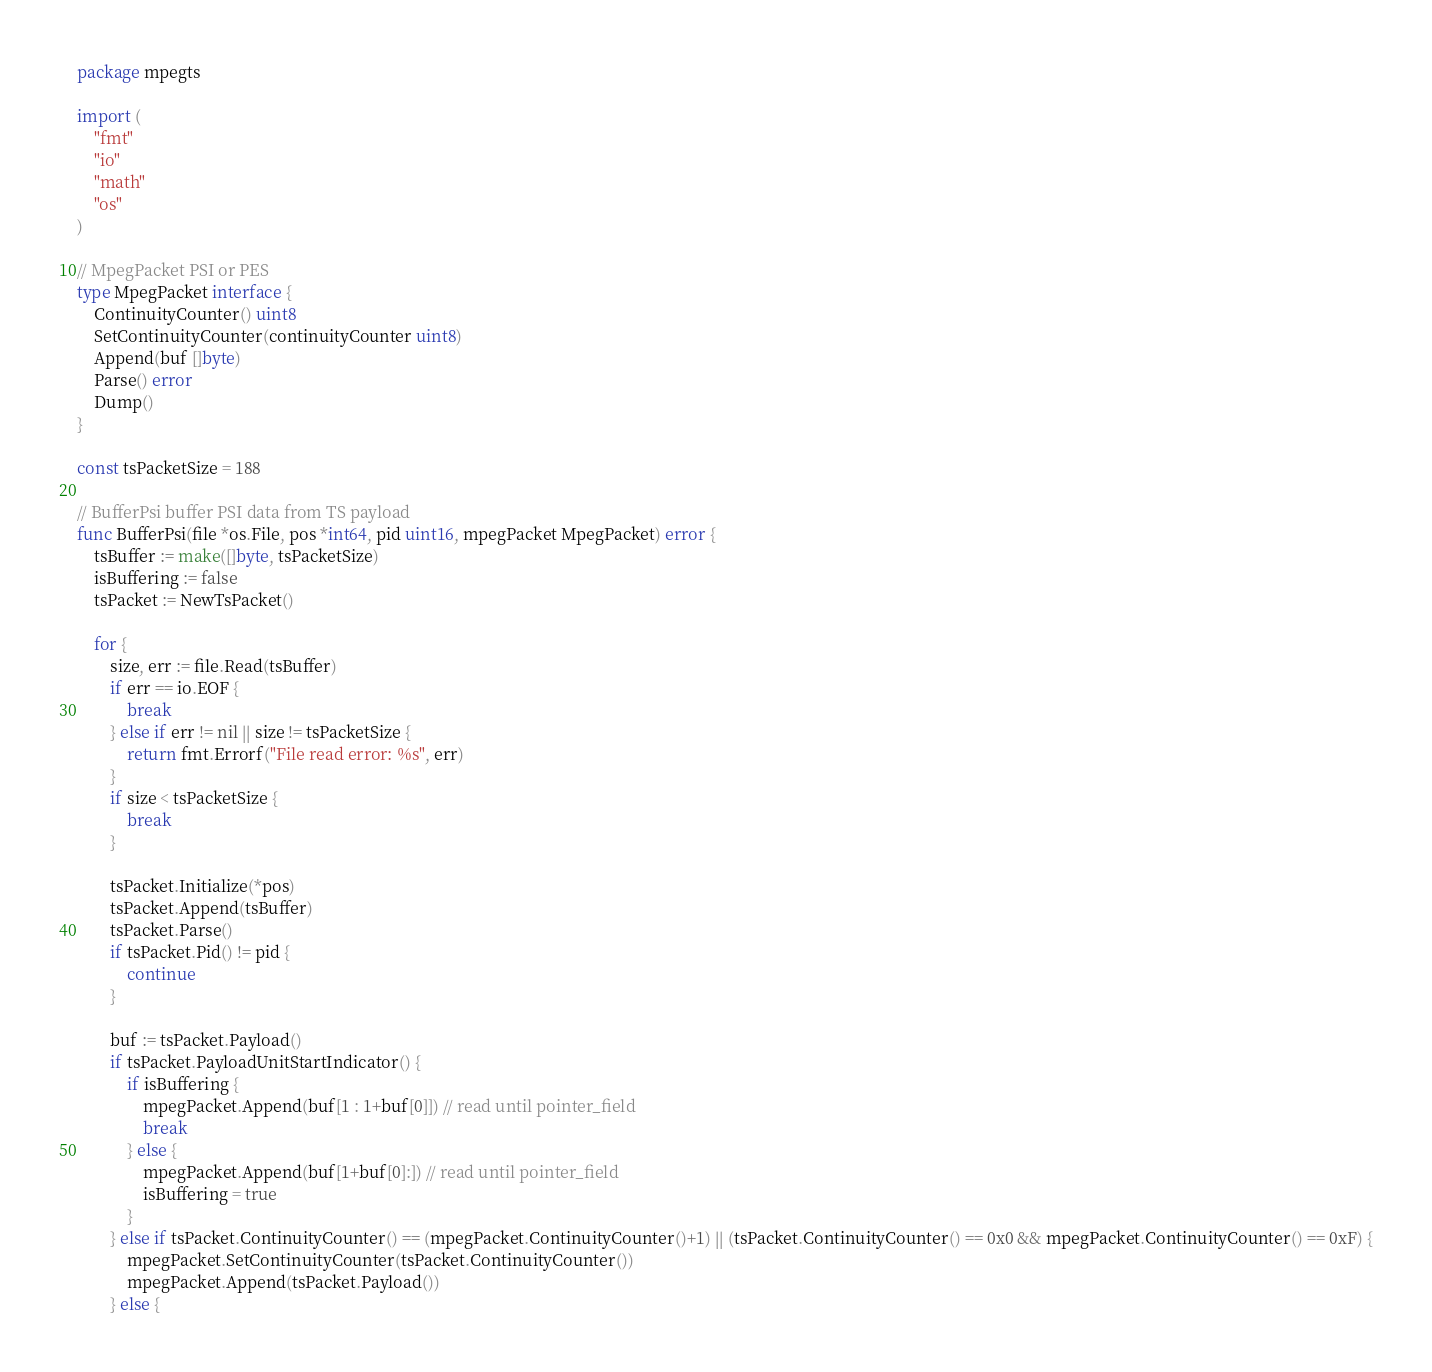Convert code to text. <code><loc_0><loc_0><loc_500><loc_500><_Go_>package mpegts

import (
	"fmt"
	"io"
	"math"
	"os"
)

// MpegPacket PSI or PES
type MpegPacket interface {
	ContinuityCounter() uint8
	SetContinuityCounter(continuityCounter uint8)
	Append(buf []byte)
	Parse() error
	Dump()
}

const tsPacketSize = 188

// BufferPsi buffer PSI data from TS payload
func BufferPsi(file *os.File, pos *int64, pid uint16, mpegPacket MpegPacket) error {
	tsBuffer := make([]byte, tsPacketSize)
	isBuffering := false
	tsPacket := NewTsPacket()

	for {
		size, err := file.Read(tsBuffer)
		if err == io.EOF {
			break
		} else if err != nil || size != tsPacketSize {
			return fmt.Errorf("File read error: %s", err)
		}
		if size < tsPacketSize {
			break
		}

		tsPacket.Initialize(*pos)
		tsPacket.Append(tsBuffer)
		tsPacket.Parse()
		if tsPacket.Pid() != pid {
			continue
		}

		buf := tsPacket.Payload()
		if tsPacket.PayloadUnitStartIndicator() {
			if isBuffering {
				mpegPacket.Append(buf[1 : 1+buf[0]]) // read until pointer_field
				break
			} else {
				mpegPacket.Append(buf[1+buf[0]:]) // read until pointer_field
				isBuffering = true
			}
		} else if tsPacket.ContinuityCounter() == (mpegPacket.ContinuityCounter()+1) || (tsPacket.ContinuityCounter() == 0x0 && mpegPacket.ContinuityCounter() == 0xF) {
			mpegPacket.SetContinuityCounter(tsPacket.ContinuityCounter())
			mpegPacket.Append(tsPacket.Payload())
		} else {</code> 